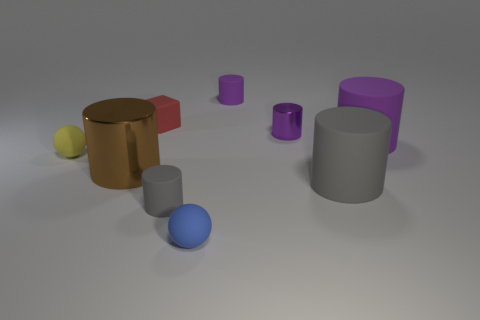Subtract all purple cylinders. How many were subtracted if there are1purple cylinders left? 2 Subtract all yellow spheres. How many purple cylinders are left? 3 Subtract 1 cylinders. How many cylinders are left? 5 Subtract all gray cylinders. How many cylinders are left? 4 Subtract all large rubber cylinders. How many cylinders are left? 4 Subtract all yellow cylinders. Subtract all purple spheres. How many cylinders are left? 6 Add 1 gray rubber cylinders. How many objects exist? 10 Subtract all large blue shiny things. Subtract all tiny yellow rubber things. How many objects are left? 8 Add 2 big rubber things. How many big rubber things are left? 4 Add 9 blue metal blocks. How many blue metal blocks exist? 9 